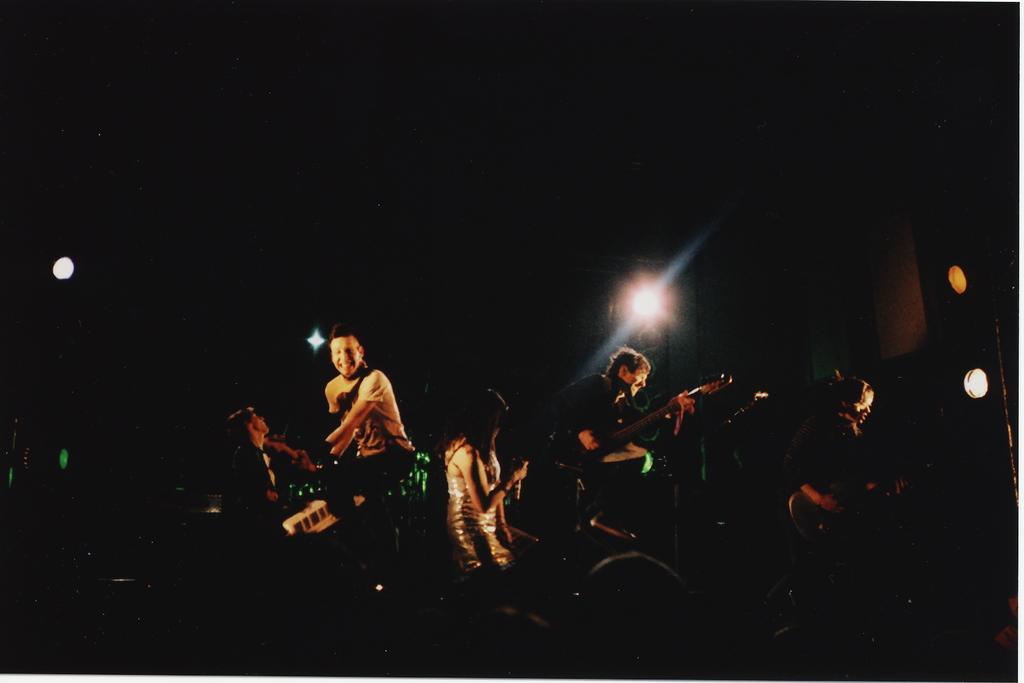Could you give a brief overview of what you see in this image? In this image i can see a group of people playing musical instrument at the background i can see a light. 